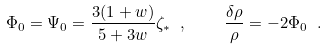Convert formula to latex. <formula><loc_0><loc_0><loc_500><loc_500>\Phi _ { 0 } = \Psi _ { 0 } = \frac { 3 ( 1 + w ) } { 5 + 3 w } \zeta _ { \ast } \ , \quad \frac { \delta \rho } { \rho } = - 2 \Phi _ { 0 } \ .</formula> 